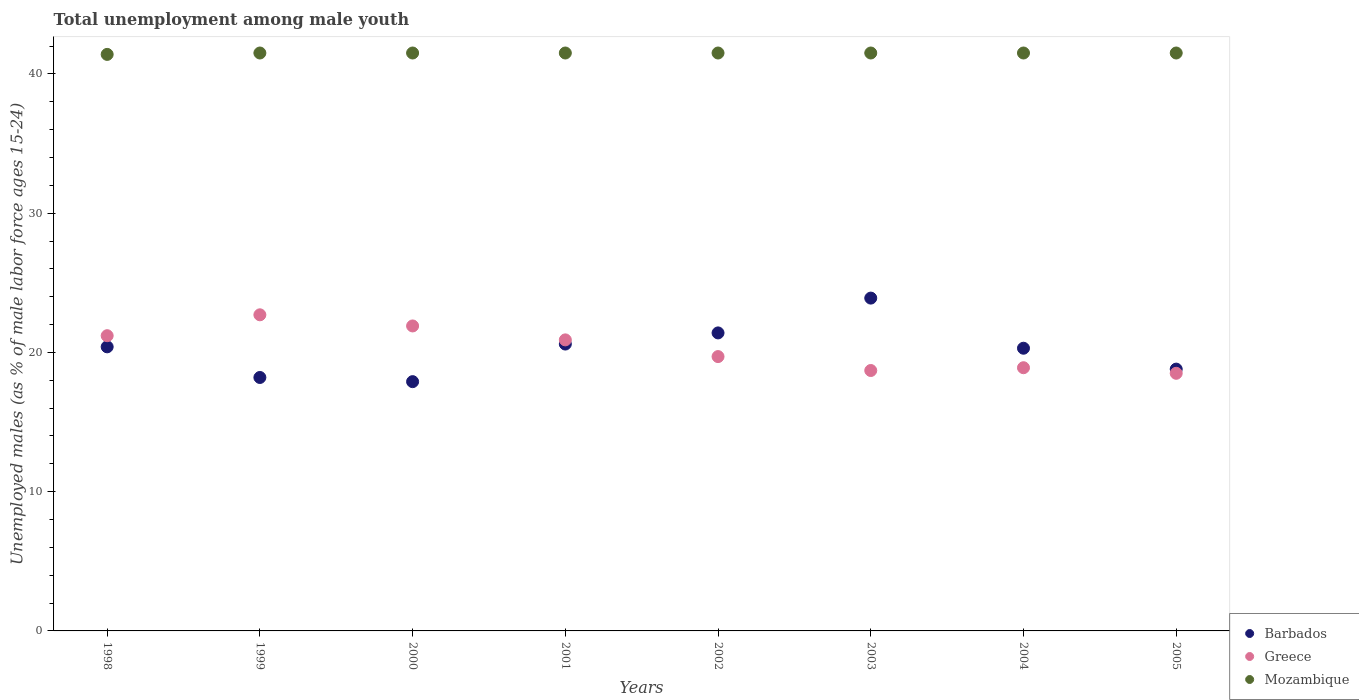Is the number of dotlines equal to the number of legend labels?
Provide a succinct answer. Yes. What is the percentage of unemployed males in in Mozambique in 2003?
Your answer should be very brief. 41.5. Across all years, what is the maximum percentage of unemployed males in in Barbados?
Provide a succinct answer. 23.9. Across all years, what is the minimum percentage of unemployed males in in Greece?
Your answer should be compact. 18.5. What is the total percentage of unemployed males in in Greece in the graph?
Make the answer very short. 162.5. What is the difference between the percentage of unemployed males in in Barbados in 2000 and that in 2001?
Provide a short and direct response. -2.7. What is the average percentage of unemployed males in in Greece per year?
Your answer should be compact. 20.31. In the year 2002, what is the difference between the percentage of unemployed males in in Greece and percentage of unemployed males in in Mozambique?
Provide a succinct answer. -21.8. In how many years, is the percentage of unemployed males in in Greece greater than 14 %?
Provide a succinct answer. 8. What is the ratio of the percentage of unemployed males in in Mozambique in 2003 to that in 2004?
Give a very brief answer. 1. Is the difference between the percentage of unemployed males in in Greece in 2002 and 2003 greater than the difference between the percentage of unemployed males in in Mozambique in 2002 and 2003?
Keep it short and to the point. Yes. What is the difference between the highest and the second highest percentage of unemployed males in in Greece?
Make the answer very short. 0.8. What is the difference between the highest and the lowest percentage of unemployed males in in Barbados?
Give a very brief answer. 6. In how many years, is the percentage of unemployed males in in Greece greater than the average percentage of unemployed males in in Greece taken over all years?
Your response must be concise. 4. Is the percentage of unemployed males in in Barbados strictly greater than the percentage of unemployed males in in Mozambique over the years?
Your answer should be very brief. No. How many dotlines are there?
Give a very brief answer. 3. What is the difference between two consecutive major ticks on the Y-axis?
Your answer should be very brief. 10. Does the graph contain any zero values?
Offer a terse response. No. Does the graph contain grids?
Your answer should be compact. No. How are the legend labels stacked?
Offer a terse response. Vertical. What is the title of the graph?
Give a very brief answer. Total unemployment among male youth. Does "Euro area" appear as one of the legend labels in the graph?
Your response must be concise. No. What is the label or title of the Y-axis?
Your answer should be very brief. Unemployed males (as % of male labor force ages 15-24). What is the Unemployed males (as % of male labor force ages 15-24) of Barbados in 1998?
Ensure brevity in your answer.  20.4. What is the Unemployed males (as % of male labor force ages 15-24) of Greece in 1998?
Your answer should be very brief. 21.2. What is the Unemployed males (as % of male labor force ages 15-24) of Mozambique in 1998?
Your answer should be compact. 41.4. What is the Unemployed males (as % of male labor force ages 15-24) in Barbados in 1999?
Offer a terse response. 18.2. What is the Unemployed males (as % of male labor force ages 15-24) of Greece in 1999?
Offer a terse response. 22.7. What is the Unemployed males (as % of male labor force ages 15-24) of Mozambique in 1999?
Your response must be concise. 41.5. What is the Unemployed males (as % of male labor force ages 15-24) in Barbados in 2000?
Your response must be concise. 17.9. What is the Unemployed males (as % of male labor force ages 15-24) of Greece in 2000?
Make the answer very short. 21.9. What is the Unemployed males (as % of male labor force ages 15-24) in Mozambique in 2000?
Your response must be concise. 41.5. What is the Unemployed males (as % of male labor force ages 15-24) in Barbados in 2001?
Offer a very short reply. 20.6. What is the Unemployed males (as % of male labor force ages 15-24) in Greece in 2001?
Keep it short and to the point. 20.9. What is the Unemployed males (as % of male labor force ages 15-24) in Mozambique in 2001?
Give a very brief answer. 41.5. What is the Unemployed males (as % of male labor force ages 15-24) in Barbados in 2002?
Your answer should be compact. 21.4. What is the Unemployed males (as % of male labor force ages 15-24) in Greece in 2002?
Your response must be concise. 19.7. What is the Unemployed males (as % of male labor force ages 15-24) of Mozambique in 2002?
Your response must be concise. 41.5. What is the Unemployed males (as % of male labor force ages 15-24) in Barbados in 2003?
Ensure brevity in your answer.  23.9. What is the Unemployed males (as % of male labor force ages 15-24) of Greece in 2003?
Keep it short and to the point. 18.7. What is the Unemployed males (as % of male labor force ages 15-24) in Mozambique in 2003?
Your answer should be compact. 41.5. What is the Unemployed males (as % of male labor force ages 15-24) in Barbados in 2004?
Provide a succinct answer. 20.3. What is the Unemployed males (as % of male labor force ages 15-24) of Greece in 2004?
Provide a short and direct response. 18.9. What is the Unemployed males (as % of male labor force ages 15-24) in Mozambique in 2004?
Offer a terse response. 41.5. What is the Unemployed males (as % of male labor force ages 15-24) in Barbados in 2005?
Offer a terse response. 18.8. What is the Unemployed males (as % of male labor force ages 15-24) of Mozambique in 2005?
Offer a terse response. 41.5. Across all years, what is the maximum Unemployed males (as % of male labor force ages 15-24) in Barbados?
Ensure brevity in your answer.  23.9. Across all years, what is the maximum Unemployed males (as % of male labor force ages 15-24) of Greece?
Offer a terse response. 22.7. Across all years, what is the maximum Unemployed males (as % of male labor force ages 15-24) of Mozambique?
Provide a succinct answer. 41.5. Across all years, what is the minimum Unemployed males (as % of male labor force ages 15-24) of Barbados?
Your response must be concise. 17.9. Across all years, what is the minimum Unemployed males (as % of male labor force ages 15-24) of Greece?
Your answer should be compact. 18.5. Across all years, what is the minimum Unemployed males (as % of male labor force ages 15-24) of Mozambique?
Keep it short and to the point. 41.4. What is the total Unemployed males (as % of male labor force ages 15-24) of Barbados in the graph?
Give a very brief answer. 161.5. What is the total Unemployed males (as % of male labor force ages 15-24) in Greece in the graph?
Offer a terse response. 162.5. What is the total Unemployed males (as % of male labor force ages 15-24) in Mozambique in the graph?
Your answer should be very brief. 331.9. What is the difference between the Unemployed males (as % of male labor force ages 15-24) in Barbados in 1998 and that in 1999?
Make the answer very short. 2.2. What is the difference between the Unemployed males (as % of male labor force ages 15-24) in Barbados in 1998 and that in 2000?
Give a very brief answer. 2.5. What is the difference between the Unemployed males (as % of male labor force ages 15-24) in Greece in 1998 and that in 2000?
Make the answer very short. -0.7. What is the difference between the Unemployed males (as % of male labor force ages 15-24) of Barbados in 1998 and that in 2001?
Ensure brevity in your answer.  -0.2. What is the difference between the Unemployed males (as % of male labor force ages 15-24) in Greece in 1998 and that in 2001?
Your answer should be compact. 0.3. What is the difference between the Unemployed males (as % of male labor force ages 15-24) in Barbados in 1998 and that in 2002?
Your answer should be compact. -1. What is the difference between the Unemployed males (as % of male labor force ages 15-24) in Barbados in 1999 and that in 2000?
Your answer should be very brief. 0.3. What is the difference between the Unemployed males (as % of male labor force ages 15-24) in Mozambique in 1999 and that in 2000?
Give a very brief answer. 0. What is the difference between the Unemployed males (as % of male labor force ages 15-24) in Barbados in 1999 and that in 2001?
Keep it short and to the point. -2.4. What is the difference between the Unemployed males (as % of male labor force ages 15-24) in Mozambique in 1999 and that in 2001?
Offer a very short reply. 0. What is the difference between the Unemployed males (as % of male labor force ages 15-24) of Barbados in 1999 and that in 2002?
Offer a terse response. -3.2. What is the difference between the Unemployed males (as % of male labor force ages 15-24) of Barbados in 1999 and that in 2003?
Make the answer very short. -5.7. What is the difference between the Unemployed males (as % of male labor force ages 15-24) of Greece in 1999 and that in 2003?
Offer a very short reply. 4. What is the difference between the Unemployed males (as % of male labor force ages 15-24) of Barbados in 1999 and that in 2004?
Make the answer very short. -2.1. What is the difference between the Unemployed males (as % of male labor force ages 15-24) of Greece in 1999 and that in 2004?
Give a very brief answer. 3.8. What is the difference between the Unemployed males (as % of male labor force ages 15-24) in Greece in 1999 and that in 2005?
Keep it short and to the point. 4.2. What is the difference between the Unemployed males (as % of male labor force ages 15-24) of Mozambique in 1999 and that in 2005?
Provide a succinct answer. 0. What is the difference between the Unemployed males (as % of male labor force ages 15-24) in Barbados in 2000 and that in 2001?
Offer a terse response. -2.7. What is the difference between the Unemployed males (as % of male labor force ages 15-24) of Greece in 2000 and that in 2001?
Your answer should be compact. 1. What is the difference between the Unemployed males (as % of male labor force ages 15-24) of Mozambique in 2000 and that in 2001?
Ensure brevity in your answer.  0. What is the difference between the Unemployed males (as % of male labor force ages 15-24) of Mozambique in 2000 and that in 2002?
Your response must be concise. 0. What is the difference between the Unemployed males (as % of male labor force ages 15-24) of Barbados in 2000 and that in 2003?
Your response must be concise. -6. What is the difference between the Unemployed males (as % of male labor force ages 15-24) in Greece in 2000 and that in 2003?
Offer a very short reply. 3.2. What is the difference between the Unemployed males (as % of male labor force ages 15-24) of Mozambique in 2000 and that in 2003?
Provide a succinct answer. 0. What is the difference between the Unemployed males (as % of male labor force ages 15-24) of Barbados in 2000 and that in 2004?
Offer a very short reply. -2.4. What is the difference between the Unemployed males (as % of male labor force ages 15-24) of Greece in 2000 and that in 2004?
Offer a very short reply. 3. What is the difference between the Unemployed males (as % of male labor force ages 15-24) in Barbados in 2000 and that in 2005?
Offer a terse response. -0.9. What is the difference between the Unemployed males (as % of male labor force ages 15-24) in Barbados in 2001 and that in 2002?
Your answer should be compact. -0.8. What is the difference between the Unemployed males (as % of male labor force ages 15-24) of Barbados in 2001 and that in 2003?
Give a very brief answer. -3.3. What is the difference between the Unemployed males (as % of male labor force ages 15-24) of Greece in 2001 and that in 2003?
Your answer should be very brief. 2.2. What is the difference between the Unemployed males (as % of male labor force ages 15-24) of Mozambique in 2001 and that in 2003?
Your response must be concise. 0. What is the difference between the Unemployed males (as % of male labor force ages 15-24) in Barbados in 2001 and that in 2004?
Offer a terse response. 0.3. What is the difference between the Unemployed males (as % of male labor force ages 15-24) of Barbados in 2001 and that in 2005?
Provide a short and direct response. 1.8. What is the difference between the Unemployed males (as % of male labor force ages 15-24) of Barbados in 2002 and that in 2003?
Offer a very short reply. -2.5. What is the difference between the Unemployed males (as % of male labor force ages 15-24) in Mozambique in 2002 and that in 2003?
Offer a very short reply. 0. What is the difference between the Unemployed males (as % of male labor force ages 15-24) in Greece in 2002 and that in 2004?
Ensure brevity in your answer.  0.8. What is the difference between the Unemployed males (as % of male labor force ages 15-24) of Mozambique in 2002 and that in 2005?
Offer a terse response. 0. What is the difference between the Unemployed males (as % of male labor force ages 15-24) in Greece in 2003 and that in 2004?
Your answer should be compact. -0.2. What is the difference between the Unemployed males (as % of male labor force ages 15-24) of Mozambique in 2003 and that in 2004?
Make the answer very short. 0. What is the difference between the Unemployed males (as % of male labor force ages 15-24) in Barbados in 2003 and that in 2005?
Your response must be concise. 5.1. What is the difference between the Unemployed males (as % of male labor force ages 15-24) of Mozambique in 2003 and that in 2005?
Your answer should be compact. 0. What is the difference between the Unemployed males (as % of male labor force ages 15-24) of Mozambique in 2004 and that in 2005?
Offer a very short reply. 0. What is the difference between the Unemployed males (as % of male labor force ages 15-24) in Barbados in 1998 and the Unemployed males (as % of male labor force ages 15-24) in Greece in 1999?
Make the answer very short. -2.3. What is the difference between the Unemployed males (as % of male labor force ages 15-24) in Barbados in 1998 and the Unemployed males (as % of male labor force ages 15-24) in Mozambique in 1999?
Keep it short and to the point. -21.1. What is the difference between the Unemployed males (as % of male labor force ages 15-24) of Greece in 1998 and the Unemployed males (as % of male labor force ages 15-24) of Mozambique in 1999?
Offer a very short reply. -20.3. What is the difference between the Unemployed males (as % of male labor force ages 15-24) of Barbados in 1998 and the Unemployed males (as % of male labor force ages 15-24) of Mozambique in 2000?
Keep it short and to the point. -21.1. What is the difference between the Unemployed males (as % of male labor force ages 15-24) of Greece in 1998 and the Unemployed males (as % of male labor force ages 15-24) of Mozambique in 2000?
Your response must be concise. -20.3. What is the difference between the Unemployed males (as % of male labor force ages 15-24) of Barbados in 1998 and the Unemployed males (as % of male labor force ages 15-24) of Mozambique in 2001?
Offer a very short reply. -21.1. What is the difference between the Unemployed males (as % of male labor force ages 15-24) of Greece in 1998 and the Unemployed males (as % of male labor force ages 15-24) of Mozambique in 2001?
Offer a very short reply. -20.3. What is the difference between the Unemployed males (as % of male labor force ages 15-24) in Barbados in 1998 and the Unemployed males (as % of male labor force ages 15-24) in Greece in 2002?
Provide a succinct answer. 0.7. What is the difference between the Unemployed males (as % of male labor force ages 15-24) in Barbados in 1998 and the Unemployed males (as % of male labor force ages 15-24) in Mozambique in 2002?
Give a very brief answer. -21.1. What is the difference between the Unemployed males (as % of male labor force ages 15-24) in Greece in 1998 and the Unemployed males (as % of male labor force ages 15-24) in Mozambique in 2002?
Give a very brief answer. -20.3. What is the difference between the Unemployed males (as % of male labor force ages 15-24) in Barbados in 1998 and the Unemployed males (as % of male labor force ages 15-24) in Greece in 2003?
Keep it short and to the point. 1.7. What is the difference between the Unemployed males (as % of male labor force ages 15-24) in Barbados in 1998 and the Unemployed males (as % of male labor force ages 15-24) in Mozambique in 2003?
Your response must be concise. -21.1. What is the difference between the Unemployed males (as % of male labor force ages 15-24) of Greece in 1998 and the Unemployed males (as % of male labor force ages 15-24) of Mozambique in 2003?
Keep it short and to the point. -20.3. What is the difference between the Unemployed males (as % of male labor force ages 15-24) of Barbados in 1998 and the Unemployed males (as % of male labor force ages 15-24) of Mozambique in 2004?
Make the answer very short. -21.1. What is the difference between the Unemployed males (as % of male labor force ages 15-24) in Greece in 1998 and the Unemployed males (as % of male labor force ages 15-24) in Mozambique in 2004?
Your answer should be compact. -20.3. What is the difference between the Unemployed males (as % of male labor force ages 15-24) of Barbados in 1998 and the Unemployed males (as % of male labor force ages 15-24) of Greece in 2005?
Offer a very short reply. 1.9. What is the difference between the Unemployed males (as % of male labor force ages 15-24) of Barbados in 1998 and the Unemployed males (as % of male labor force ages 15-24) of Mozambique in 2005?
Give a very brief answer. -21.1. What is the difference between the Unemployed males (as % of male labor force ages 15-24) in Greece in 1998 and the Unemployed males (as % of male labor force ages 15-24) in Mozambique in 2005?
Give a very brief answer. -20.3. What is the difference between the Unemployed males (as % of male labor force ages 15-24) in Barbados in 1999 and the Unemployed males (as % of male labor force ages 15-24) in Greece in 2000?
Keep it short and to the point. -3.7. What is the difference between the Unemployed males (as % of male labor force ages 15-24) in Barbados in 1999 and the Unemployed males (as % of male labor force ages 15-24) in Mozambique in 2000?
Keep it short and to the point. -23.3. What is the difference between the Unemployed males (as % of male labor force ages 15-24) of Greece in 1999 and the Unemployed males (as % of male labor force ages 15-24) of Mozambique in 2000?
Ensure brevity in your answer.  -18.8. What is the difference between the Unemployed males (as % of male labor force ages 15-24) in Barbados in 1999 and the Unemployed males (as % of male labor force ages 15-24) in Mozambique in 2001?
Provide a succinct answer. -23.3. What is the difference between the Unemployed males (as % of male labor force ages 15-24) of Greece in 1999 and the Unemployed males (as % of male labor force ages 15-24) of Mozambique in 2001?
Provide a succinct answer. -18.8. What is the difference between the Unemployed males (as % of male labor force ages 15-24) of Barbados in 1999 and the Unemployed males (as % of male labor force ages 15-24) of Mozambique in 2002?
Give a very brief answer. -23.3. What is the difference between the Unemployed males (as % of male labor force ages 15-24) of Greece in 1999 and the Unemployed males (as % of male labor force ages 15-24) of Mozambique in 2002?
Make the answer very short. -18.8. What is the difference between the Unemployed males (as % of male labor force ages 15-24) of Barbados in 1999 and the Unemployed males (as % of male labor force ages 15-24) of Mozambique in 2003?
Provide a short and direct response. -23.3. What is the difference between the Unemployed males (as % of male labor force ages 15-24) of Greece in 1999 and the Unemployed males (as % of male labor force ages 15-24) of Mozambique in 2003?
Your answer should be very brief. -18.8. What is the difference between the Unemployed males (as % of male labor force ages 15-24) in Barbados in 1999 and the Unemployed males (as % of male labor force ages 15-24) in Greece in 2004?
Offer a terse response. -0.7. What is the difference between the Unemployed males (as % of male labor force ages 15-24) of Barbados in 1999 and the Unemployed males (as % of male labor force ages 15-24) of Mozambique in 2004?
Offer a very short reply. -23.3. What is the difference between the Unemployed males (as % of male labor force ages 15-24) of Greece in 1999 and the Unemployed males (as % of male labor force ages 15-24) of Mozambique in 2004?
Ensure brevity in your answer.  -18.8. What is the difference between the Unemployed males (as % of male labor force ages 15-24) of Barbados in 1999 and the Unemployed males (as % of male labor force ages 15-24) of Mozambique in 2005?
Your answer should be very brief. -23.3. What is the difference between the Unemployed males (as % of male labor force ages 15-24) of Greece in 1999 and the Unemployed males (as % of male labor force ages 15-24) of Mozambique in 2005?
Offer a very short reply. -18.8. What is the difference between the Unemployed males (as % of male labor force ages 15-24) of Barbados in 2000 and the Unemployed males (as % of male labor force ages 15-24) of Greece in 2001?
Ensure brevity in your answer.  -3. What is the difference between the Unemployed males (as % of male labor force ages 15-24) of Barbados in 2000 and the Unemployed males (as % of male labor force ages 15-24) of Mozambique in 2001?
Keep it short and to the point. -23.6. What is the difference between the Unemployed males (as % of male labor force ages 15-24) of Greece in 2000 and the Unemployed males (as % of male labor force ages 15-24) of Mozambique in 2001?
Make the answer very short. -19.6. What is the difference between the Unemployed males (as % of male labor force ages 15-24) of Barbados in 2000 and the Unemployed males (as % of male labor force ages 15-24) of Mozambique in 2002?
Make the answer very short. -23.6. What is the difference between the Unemployed males (as % of male labor force ages 15-24) of Greece in 2000 and the Unemployed males (as % of male labor force ages 15-24) of Mozambique in 2002?
Keep it short and to the point. -19.6. What is the difference between the Unemployed males (as % of male labor force ages 15-24) in Barbados in 2000 and the Unemployed males (as % of male labor force ages 15-24) in Greece in 2003?
Give a very brief answer. -0.8. What is the difference between the Unemployed males (as % of male labor force ages 15-24) in Barbados in 2000 and the Unemployed males (as % of male labor force ages 15-24) in Mozambique in 2003?
Keep it short and to the point. -23.6. What is the difference between the Unemployed males (as % of male labor force ages 15-24) in Greece in 2000 and the Unemployed males (as % of male labor force ages 15-24) in Mozambique in 2003?
Keep it short and to the point. -19.6. What is the difference between the Unemployed males (as % of male labor force ages 15-24) in Barbados in 2000 and the Unemployed males (as % of male labor force ages 15-24) in Mozambique in 2004?
Your answer should be very brief. -23.6. What is the difference between the Unemployed males (as % of male labor force ages 15-24) in Greece in 2000 and the Unemployed males (as % of male labor force ages 15-24) in Mozambique in 2004?
Give a very brief answer. -19.6. What is the difference between the Unemployed males (as % of male labor force ages 15-24) of Barbados in 2000 and the Unemployed males (as % of male labor force ages 15-24) of Mozambique in 2005?
Give a very brief answer. -23.6. What is the difference between the Unemployed males (as % of male labor force ages 15-24) of Greece in 2000 and the Unemployed males (as % of male labor force ages 15-24) of Mozambique in 2005?
Make the answer very short. -19.6. What is the difference between the Unemployed males (as % of male labor force ages 15-24) of Barbados in 2001 and the Unemployed males (as % of male labor force ages 15-24) of Mozambique in 2002?
Give a very brief answer. -20.9. What is the difference between the Unemployed males (as % of male labor force ages 15-24) in Greece in 2001 and the Unemployed males (as % of male labor force ages 15-24) in Mozambique in 2002?
Provide a short and direct response. -20.6. What is the difference between the Unemployed males (as % of male labor force ages 15-24) in Barbados in 2001 and the Unemployed males (as % of male labor force ages 15-24) in Mozambique in 2003?
Ensure brevity in your answer.  -20.9. What is the difference between the Unemployed males (as % of male labor force ages 15-24) of Greece in 2001 and the Unemployed males (as % of male labor force ages 15-24) of Mozambique in 2003?
Provide a short and direct response. -20.6. What is the difference between the Unemployed males (as % of male labor force ages 15-24) in Barbados in 2001 and the Unemployed males (as % of male labor force ages 15-24) in Mozambique in 2004?
Your answer should be compact. -20.9. What is the difference between the Unemployed males (as % of male labor force ages 15-24) of Greece in 2001 and the Unemployed males (as % of male labor force ages 15-24) of Mozambique in 2004?
Keep it short and to the point. -20.6. What is the difference between the Unemployed males (as % of male labor force ages 15-24) in Barbados in 2001 and the Unemployed males (as % of male labor force ages 15-24) in Greece in 2005?
Your response must be concise. 2.1. What is the difference between the Unemployed males (as % of male labor force ages 15-24) of Barbados in 2001 and the Unemployed males (as % of male labor force ages 15-24) of Mozambique in 2005?
Your answer should be compact. -20.9. What is the difference between the Unemployed males (as % of male labor force ages 15-24) in Greece in 2001 and the Unemployed males (as % of male labor force ages 15-24) in Mozambique in 2005?
Offer a terse response. -20.6. What is the difference between the Unemployed males (as % of male labor force ages 15-24) in Barbados in 2002 and the Unemployed males (as % of male labor force ages 15-24) in Greece in 2003?
Provide a short and direct response. 2.7. What is the difference between the Unemployed males (as % of male labor force ages 15-24) in Barbados in 2002 and the Unemployed males (as % of male labor force ages 15-24) in Mozambique in 2003?
Ensure brevity in your answer.  -20.1. What is the difference between the Unemployed males (as % of male labor force ages 15-24) in Greece in 2002 and the Unemployed males (as % of male labor force ages 15-24) in Mozambique in 2003?
Give a very brief answer. -21.8. What is the difference between the Unemployed males (as % of male labor force ages 15-24) in Barbados in 2002 and the Unemployed males (as % of male labor force ages 15-24) in Mozambique in 2004?
Ensure brevity in your answer.  -20.1. What is the difference between the Unemployed males (as % of male labor force ages 15-24) in Greece in 2002 and the Unemployed males (as % of male labor force ages 15-24) in Mozambique in 2004?
Provide a succinct answer. -21.8. What is the difference between the Unemployed males (as % of male labor force ages 15-24) in Barbados in 2002 and the Unemployed males (as % of male labor force ages 15-24) in Mozambique in 2005?
Make the answer very short. -20.1. What is the difference between the Unemployed males (as % of male labor force ages 15-24) of Greece in 2002 and the Unemployed males (as % of male labor force ages 15-24) of Mozambique in 2005?
Your answer should be compact. -21.8. What is the difference between the Unemployed males (as % of male labor force ages 15-24) of Barbados in 2003 and the Unemployed males (as % of male labor force ages 15-24) of Greece in 2004?
Give a very brief answer. 5. What is the difference between the Unemployed males (as % of male labor force ages 15-24) of Barbados in 2003 and the Unemployed males (as % of male labor force ages 15-24) of Mozambique in 2004?
Your response must be concise. -17.6. What is the difference between the Unemployed males (as % of male labor force ages 15-24) of Greece in 2003 and the Unemployed males (as % of male labor force ages 15-24) of Mozambique in 2004?
Your answer should be compact. -22.8. What is the difference between the Unemployed males (as % of male labor force ages 15-24) in Barbados in 2003 and the Unemployed males (as % of male labor force ages 15-24) in Greece in 2005?
Your answer should be compact. 5.4. What is the difference between the Unemployed males (as % of male labor force ages 15-24) of Barbados in 2003 and the Unemployed males (as % of male labor force ages 15-24) of Mozambique in 2005?
Your answer should be compact. -17.6. What is the difference between the Unemployed males (as % of male labor force ages 15-24) in Greece in 2003 and the Unemployed males (as % of male labor force ages 15-24) in Mozambique in 2005?
Offer a terse response. -22.8. What is the difference between the Unemployed males (as % of male labor force ages 15-24) in Barbados in 2004 and the Unemployed males (as % of male labor force ages 15-24) in Greece in 2005?
Give a very brief answer. 1.8. What is the difference between the Unemployed males (as % of male labor force ages 15-24) in Barbados in 2004 and the Unemployed males (as % of male labor force ages 15-24) in Mozambique in 2005?
Ensure brevity in your answer.  -21.2. What is the difference between the Unemployed males (as % of male labor force ages 15-24) of Greece in 2004 and the Unemployed males (as % of male labor force ages 15-24) of Mozambique in 2005?
Offer a terse response. -22.6. What is the average Unemployed males (as % of male labor force ages 15-24) of Barbados per year?
Your response must be concise. 20.19. What is the average Unemployed males (as % of male labor force ages 15-24) of Greece per year?
Make the answer very short. 20.31. What is the average Unemployed males (as % of male labor force ages 15-24) in Mozambique per year?
Offer a terse response. 41.49. In the year 1998, what is the difference between the Unemployed males (as % of male labor force ages 15-24) of Barbados and Unemployed males (as % of male labor force ages 15-24) of Mozambique?
Provide a succinct answer. -21. In the year 1998, what is the difference between the Unemployed males (as % of male labor force ages 15-24) of Greece and Unemployed males (as % of male labor force ages 15-24) of Mozambique?
Give a very brief answer. -20.2. In the year 1999, what is the difference between the Unemployed males (as % of male labor force ages 15-24) in Barbados and Unemployed males (as % of male labor force ages 15-24) in Mozambique?
Keep it short and to the point. -23.3. In the year 1999, what is the difference between the Unemployed males (as % of male labor force ages 15-24) in Greece and Unemployed males (as % of male labor force ages 15-24) in Mozambique?
Give a very brief answer. -18.8. In the year 2000, what is the difference between the Unemployed males (as % of male labor force ages 15-24) in Barbados and Unemployed males (as % of male labor force ages 15-24) in Mozambique?
Provide a succinct answer. -23.6. In the year 2000, what is the difference between the Unemployed males (as % of male labor force ages 15-24) of Greece and Unemployed males (as % of male labor force ages 15-24) of Mozambique?
Offer a terse response. -19.6. In the year 2001, what is the difference between the Unemployed males (as % of male labor force ages 15-24) of Barbados and Unemployed males (as % of male labor force ages 15-24) of Greece?
Provide a short and direct response. -0.3. In the year 2001, what is the difference between the Unemployed males (as % of male labor force ages 15-24) of Barbados and Unemployed males (as % of male labor force ages 15-24) of Mozambique?
Your answer should be very brief. -20.9. In the year 2001, what is the difference between the Unemployed males (as % of male labor force ages 15-24) of Greece and Unemployed males (as % of male labor force ages 15-24) of Mozambique?
Keep it short and to the point. -20.6. In the year 2002, what is the difference between the Unemployed males (as % of male labor force ages 15-24) in Barbados and Unemployed males (as % of male labor force ages 15-24) in Mozambique?
Provide a succinct answer. -20.1. In the year 2002, what is the difference between the Unemployed males (as % of male labor force ages 15-24) of Greece and Unemployed males (as % of male labor force ages 15-24) of Mozambique?
Provide a succinct answer. -21.8. In the year 2003, what is the difference between the Unemployed males (as % of male labor force ages 15-24) of Barbados and Unemployed males (as % of male labor force ages 15-24) of Greece?
Provide a short and direct response. 5.2. In the year 2003, what is the difference between the Unemployed males (as % of male labor force ages 15-24) of Barbados and Unemployed males (as % of male labor force ages 15-24) of Mozambique?
Ensure brevity in your answer.  -17.6. In the year 2003, what is the difference between the Unemployed males (as % of male labor force ages 15-24) in Greece and Unemployed males (as % of male labor force ages 15-24) in Mozambique?
Keep it short and to the point. -22.8. In the year 2004, what is the difference between the Unemployed males (as % of male labor force ages 15-24) in Barbados and Unemployed males (as % of male labor force ages 15-24) in Greece?
Offer a very short reply. 1.4. In the year 2004, what is the difference between the Unemployed males (as % of male labor force ages 15-24) of Barbados and Unemployed males (as % of male labor force ages 15-24) of Mozambique?
Provide a short and direct response. -21.2. In the year 2004, what is the difference between the Unemployed males (as % of male labor force ages 15-24) of Greece and Unemployed males (as % of male labor force ages 15-24) of Mozambique?
Provide a succinct answer. -22.6. In the year 2005, what is the difference between the Unemployed males (as % of male labor force ages 15-24) of Barbados and Unemployed males (as % of male labor force ages 15-24) of Mozambique?
Provide a short and direct response. -22.7. In the year 2005, what is the difference between the Unemployed males (as % of male labor force ages 15-24) of Greece and Unemployed males (as % of male labor force ages 15-24) of Mozambique?
Provide a succinct answer. -23. What is the ratio of the Unemployed males (as % of male labor force ages 15-24) in Barbados in 1998 to that in 1999?
Your answer should be compact. 1.12. What is the ratio of the Unemployed males (as % of male labor force ages 15-24) in Greece in 1998 to that in 1999?
Your answer should be compact. 0.93. What is the ratio of the Unemployed males (as % of male labor force ages 15-24) in Mozambique in 1998 to that in 1999?
Your response must be concise. 1. What is the ratio of the Unemployed males (as % of male labor force ages 15-24) of Barbados in 1998 to that in 2000?
Keep it short and to the point. 1.14. What is the ratio of the Unemployed males (as % of male labor force ages 15-24) in Greece in 1998 to that in 2000?
Keep it short and to the point. 0.97. What is the ratio of the Unemployed males (as % of male labor force ages 15-24) of Barbados in 1998 to that in 2001?
Ensure brevity in your answer.  0.99. What is the ratio of the Unemployed males (as % of male labor force ages 15-24) in Greece in 1998 to that in 2001?
Provide a succinct answer. 1.01. What is the ratio of the Unemployed males (as % of male labor force ages 15-24) in Mozambique in 1998 to that in 2001?
Provide a short and direct response. 1. What is the ratio of the Unemployed males (as % of male labor force ages 15-24) in Barbados in 1998 to that in 2002?
Your answer should be compact. 0.95. What is the ratio of the Unemployed males (as % of male labor force ages 15-24) of Greece in 1998 to that in 2002?
Ensure brevity in your answer.  1.08. What is the ratio of the Unemployed males (as % of male labor force ages 15-24) in Barbados in 1998 to that in 2003?
Your response must be concise. 0.85. What is the ratio of the Unemployed males (as % of male labor force ages 15-24) in Greece in 1998 to that in 2003?
Offer a terse response. 1.13. What is the ratio of the Unemployed males (as % of male labor force ages 15-24) of Barbados in 1998 to that in 2004?
Offer a very short reply. 1. What is the ratio of the Unemployed males (as % of male labor force ages 15-24) in Greece in 1998 to that in 2004?
Provide a succinct answer. 1.12. What is the ratio of the Unemployed males (as % of male labor force ages 15-24) of Barbados in 1998 to that in 2005?
Provide a short and direct response. 1.09. What is the ratio of the Unemployed males (as % of male labor force ages 15-24) of Greece in 1998 to that in 2005?
Provide a short and direct response. 1.15. What is the ratio of the Unemployed males (as % of male labor force ages 15-24) in Barbados in 1999 to that in 2000?
Your answer should be compact. 1.02. What is the ratio of the Unemployed males (as % of male labor force ages 15-24) in Greece in 1999 to that in 2000?
Give a very brief answer. 1.04. What is the ratio of the Unemployed males (as % of male labor force ages 15-24) of Mozambique in 1999 to that in 2000?
Give a very brief answer. 1. What is the ratio of the Unemployed males (as % of male labor force ages 15-24) of Barbados in 1999 to that in 2001?
Your answer should be very brief. 0.88. What is the ratio of the Unemployed males (as % of male labor force ages 15-24) in Greece in 1999 to that in 2001?
Give a very brief answer. 1.09. What is the ratio of the Unemployed males (as % of male labor force ages 15-24) of Barbados in 1999 to that in 2002?
Your answer should be compact. 0.85. What is the ratio of the Unemployed males (as % of male labor force ages 15-24) in Greece in 1999 to that in 2002?
Make the answer very short. 1.15. What is the ratio of the Unemployed males (as % of male labor force ages 15-24) of Barbados in 1999 to that in 2003?
Offer a terse response. 0.76. What is the ratio of the Unemployed males (as % of male labor force ages 15-24) in Greece in 1999 to that in 2003?
Make the answer very short. 1.21. What is the ratio of the Unemployed males (as % of male labor force ages 15-24) of Barbados in 1999 to that in 2004?
Offer a terse response. 0.9. What is the ratio of the Unemployed males (as % of male labor force ages 15-24) of Greece in 1999 to that in 2004?
Your answer should be very brief. 1.2. What is the ratio of the Unemployed males (as % of male labor force ages 15-24) of Barbados in 1999 to that in 2005?
Keep it short and to the point. 0.97. What is the ratio of the Unemployed males (as % of male labor force ages 15-24) of Greece in 1999 to that in 2005?
Provide a short and direct response. 1.23. What is the ratio of the Unemployed males (as % of male labor force ages 15-24) in Barbados in 2000 to that in 2001?
Provide a succinct answer. 0.87. What is the ratio of the Unemployed males (as % of male labor force ages 15-24) in Greece in 2000 to that in 2001?
Your answer should be compact. 1.05. What is the ratio of the Unemployed males (as % of male labor force ages 15-24) in Barbados in 2000 to that in 2002?
Ensure brevity in your answer.  0.84. What is the ratio of the Unemployed males (as % of male labor force ages 15-24) in Greece in 2000 to that in 2002?
Provide a succinct answer. 1.11. What is the ratio of the Unemployed males (as % of male labor force ages 15-24) of Mozambique in 2000 to that in 2002?
Your answer should be very brief. 1. What is the ratio of the Unemployed males (as % of male labor force ages 15-24) of Barbados in 2000 to that in 2003?
Make the answer very short. 0.75. What is the ratio of the Unemployed males (as % of male labor force ages 15-24) in Greece in 2000 to that in 2003?
Offer a terse response. 1.17. What is the ratio of the Unemployed males (as % of male labor force ages 15-24) in Mozambique in 2000 to that in 2003?
Your answer should be compact. 1. What is the ratio of the Unemployed males (as % of male labor force ages 15-24) in Barbados in 2000 to that in 2004?
Ensure brevity in your answer.  0.88. What is the ratio of the Unemployed males (as % of male labor force ages 15-24) in Greece in 2000 to that in 2004?
Offer a terse response. 1.16. What is the ratio of the Unemployed males (as % of male labor force ages 15-24) of Barbados in 2000 to that in 2005?
Make the answer very short. 0.95. What is the ratio of the Unemployed males (as % of male labor force ages 15-24) of Greece in 2000 to that in 2005?
Provide a short and direct response. 1.18. What is the ratio of the Unemployed males (as % of male labor force ages 15-24) of Mozambique in 2000 to that in 2005?
Make the answer very short. 1. What is the ratio of the Unemployed males (as % of male labor force ages 15-24) in Barbados in 2001 to that in 2002?
Your answer should be very brief. 0.96. What is the ratio of the Unemployed males (as % of male labor force ages 15-24) in Greece in 2001 to that in 2002?
Ensure brevity in your answer.  1.06. What is the ratio of the Unemployed males (as % of male labor force ages 15-24) in Mozambique in 2001 to that in 2002?
Give a very brief answer. 1. What is the ratio of the Unemployed males (as % of male labor force ages 15-24) of Barbados in 2001 to that in 2003?
Make the answer very short. 0.86. What is the ratio of the Unemployed males (as % of male labor force ages 15-24) of Greece in 2001 to that in 2003?
Your answer should be very brief. 1.12. What is the ratio of the Unemployed males (as % of male labor force ages 15-24) in Mozambique in 2001 to that in 2003?
Give a very brief answer. 1. What is the ratio of the Unemployed males (as % of male labor force ages 15-24) of Barbados in 2001 to that in 2004?
Your answer should be very brief. 1.01. What is the ratio of the Unemployed males (as % of male labor force ages 15-24) in Greece in 2001 to that in 2004?
Keep it short and to the point. 1.11. What is the ratio of the Unemployed males (as % of male labor force ages 15-24) in Barbados in 2001 to that in 2005?
Your answer should be very brief. 1.1. What is the ratio of the Unemployed males (as % of male labor force ages 15-24) of Greece in 2001 to that in 2005?
Your answer should be compact. 1.13. What is the ratio of the Unemployed males (as % of male labor force ages 15-24) of Barbados in 2002 to that in 2003?
Ensure brevity in your answer.  0.9. What is the ratio of the Unemployed males (as % of male labor force ages 15-24) in Greece in 2002 to that in 2003?
Offer a terse response. 1.05. What is the ratio of the Unemployed males (as % of male labor force ages 15-24) of Barbados in 2002 to that in 2004?
Give a very brief answer. 1.05. What is the ratio of the Unemployed males (as % of male labor force ages 15-24) of Greece in 2002 to that in 2004?
Provide a succinct answer. 1.04. What is the ratio of the Unemployed males (as % of male labor force ages 15-24) of Mozambique in 2002 to that in 2004?
Your answer should be compact. 1. What is the ratio of the Unemployed males (as % of male labor force ages 15-24) of Barbados in 2002 to that in 2005?
Keep it short and to the point. 1.14. What is the ratio of the Unemployed males (as % of male labor force ages 15-24) of Greece in 2002 to that in 2005?
Make the answer very short. 1.06. What is the ratio of the Unemployed males (as % of male labor force ages 15-24) in Barbados in 2003 to that in 2004?
Offer a terse response. 1.18. What is the ratio of the Unemployed males (as % of male labor force ages 15-24) in Greece in 2003 to that in 2004?
Your response must be concise. 0.99. What is the ratio of the Unemployed males (as % of male labor force ages 15-24) in Mozambique in 2003 to that in 2004?
Your answer should be compact. 1. What is the ratio of the Unemployed males (as % of male labor force ages 15-24) in Barbados in 2003 to that in 2005?
Provide a short and direct response. 1.27. What is the ratio of the Unemployed males (as % of male labor force ages 15-24) of Greece in 2003 to that in 2005?
Provide a short and direct response. 1.01. What is the ratio of the Unemployed males (as % of male labor force ages 15-24) in Mozambique in 2003 to that in 2005?
Ensure brevity in your answer.  1. What is the ratio of the Unemployed males (as % of male labor force ages 15-24) of Barbados in 2004 to that in 2005?
Ensure brevity in your answer.  1.08. What is the ratio of the Unemployed males (as % of male labor force ages 15-24) of Greece in 2004 to that in 2005?
Your response must be concise. 1.02. What is the ratio of the Unemployed males (as % of male labor force ages 15-24) of Mozambique in 2004 to that in 2005?
Your answer should be very brief. 1. What is the difference between the highest and the lowest Unemployed males (as % of male labor force ages 15-24) in Barbados?
Provide a succinct answer. 6. 